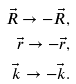Convert formula to latex. <formula><loc_0><loc_0><loc_500><loc_500>\vec { R } \rightarrow - \vec { R } , \\ \vec { r } \rightarrow - \vec { r } , \\ \vec { k } \rightarrow - \vec { k } .</formula> 